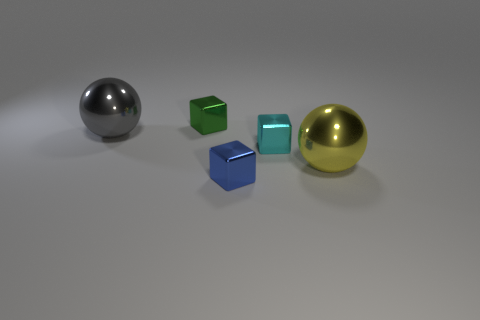What size is the shiny object that is in front of the tiny green cube and to the left of the blue metallic object?
Give a very brief answer. Large. There is a small thing in front of the yellow sphere; what is its shape?
Ensure brevity in your answer.  Cube. Are the small cyan object and the ball on the right side of the tiny green shiny object made of the same material?
Your answer should be very brief. Yes. Is the shape of the big yellow thing the same as the large gray thing?
Offer a terse response. Yes. What is the color of the tiny block that is behind the large yellow shiny sphere and in front of the green shiny cube?
Keep it short and to the point. Cyan. Are there any other small cyan objects of the same shape as the small cyan metallic object?
Give a very brief answer. No. What is the size of the blue thing in front of the cyan object?
Your answer should be very brief. Small. Is the number of large gray spheres greater than the number of tiny metal cubes?
Offer a terse response. No. There is a block that is behind the small cube that is to the right of the blue cube; how big is it?
Give a very brief answer. Small. There is a blue metal object that is the same size as the cyan metal object; what shape is it?
Offer a very short reply. Cube. 